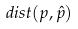Convert formula to latex. <formula><loc_0><loc_0><loc_500><loc_500>d i s t ( p , \hat { p } )</formula> 